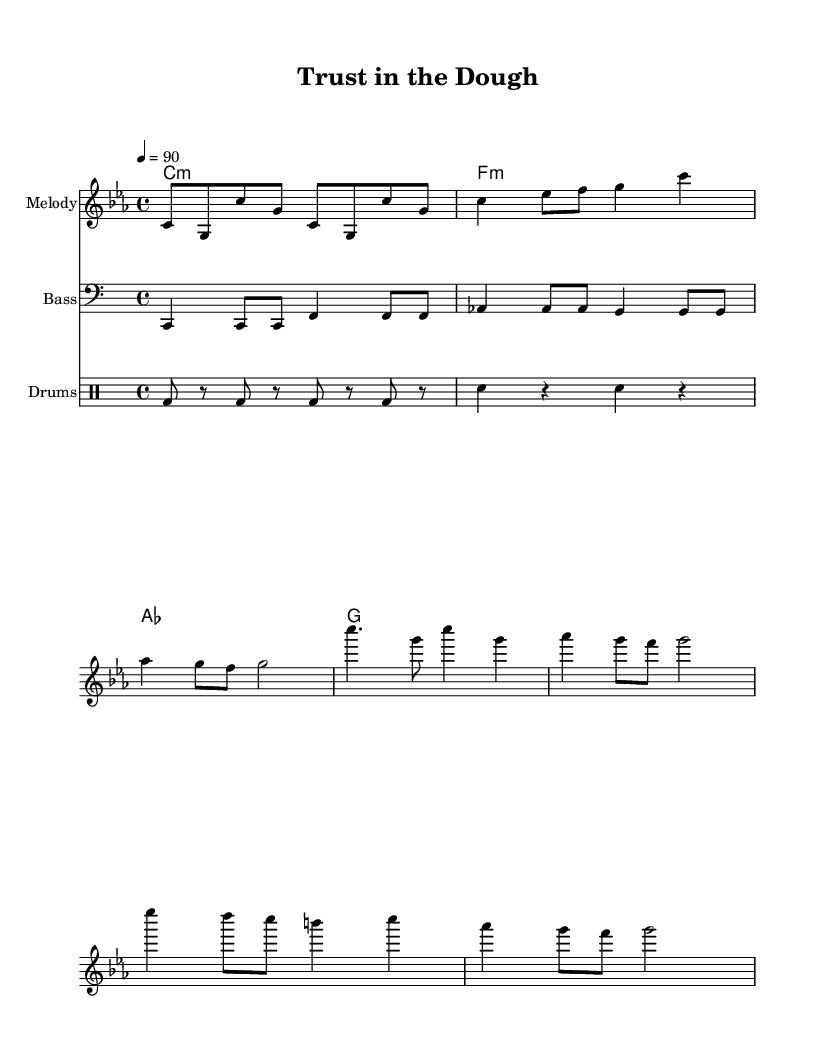What is the key signature of this music? The key signature is indicated at the beginning of the score. It shows three flats, which corresponds to C minor.
Answer: C minor What is the time signature of this music? The time signature is located right after the key signature at the beginning of the score. It is indicated as 4/4, meaning there are four beats in each measure.
Answer: 4/4 What is the tempo marking for this music? The tempo marking appears in the score specifying the speed. It indicates a tempo of quarter note equals 90 beats per minute.
Answer: 90 How many measures are in the verse section? To determine this, we look at the verse section, which is from the beginning to the last note before the chorus starts. Counting the measures, we find there are four measures in the verse section.
Answer: 4 How does the chorus differ in lyrics from the verse? The chorus lyrics are distinct from the verse and emphasize themes of trust and loyalty in customer service, contrasting with the verse, which addresses the business itself.
Answer: Trust and loyalty What elements are included in the arrangement of this hip hop anthem? The music is structured with melody, bass, harmony, and drums, all of which are standard elements in hip hop music to create a rhythm and support themes.
Answer: Melody, bass, harmony, and drums What is the rhythm pattern for the drums? The drum rhythm is dictated by the notation in the drum staff, specifically indicating a bass drum on the eighth notes and snare on the quarter notes, forming a typical hip hop rhythm pattern.
Answer: Bass drum and snare 